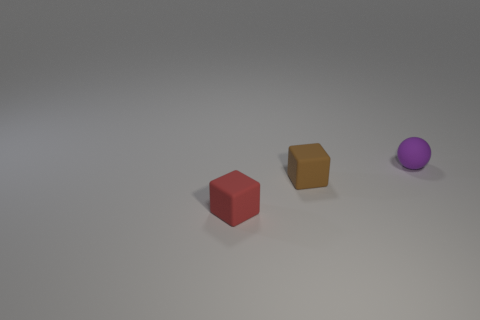Add 1 gray metal blocks. How many objects exist? 4 Add 1 brown blocks. How many brown blocks are left? 2 Add 3 purple cubes. How many purple cubes exist? 3 Subtract 0 green spheres. How many objects are left? 3 Subtract all balls. How many objects are left? 2 Subtract all gray cubes. Subtract all yellow spheres. How many cubes are left? 2 Subtract all cyan cylinders. How many brown cubes are left? 1 Subtract all small matte spheres. Subtract all tiny brown matte cubes. How many objects are left? 1 